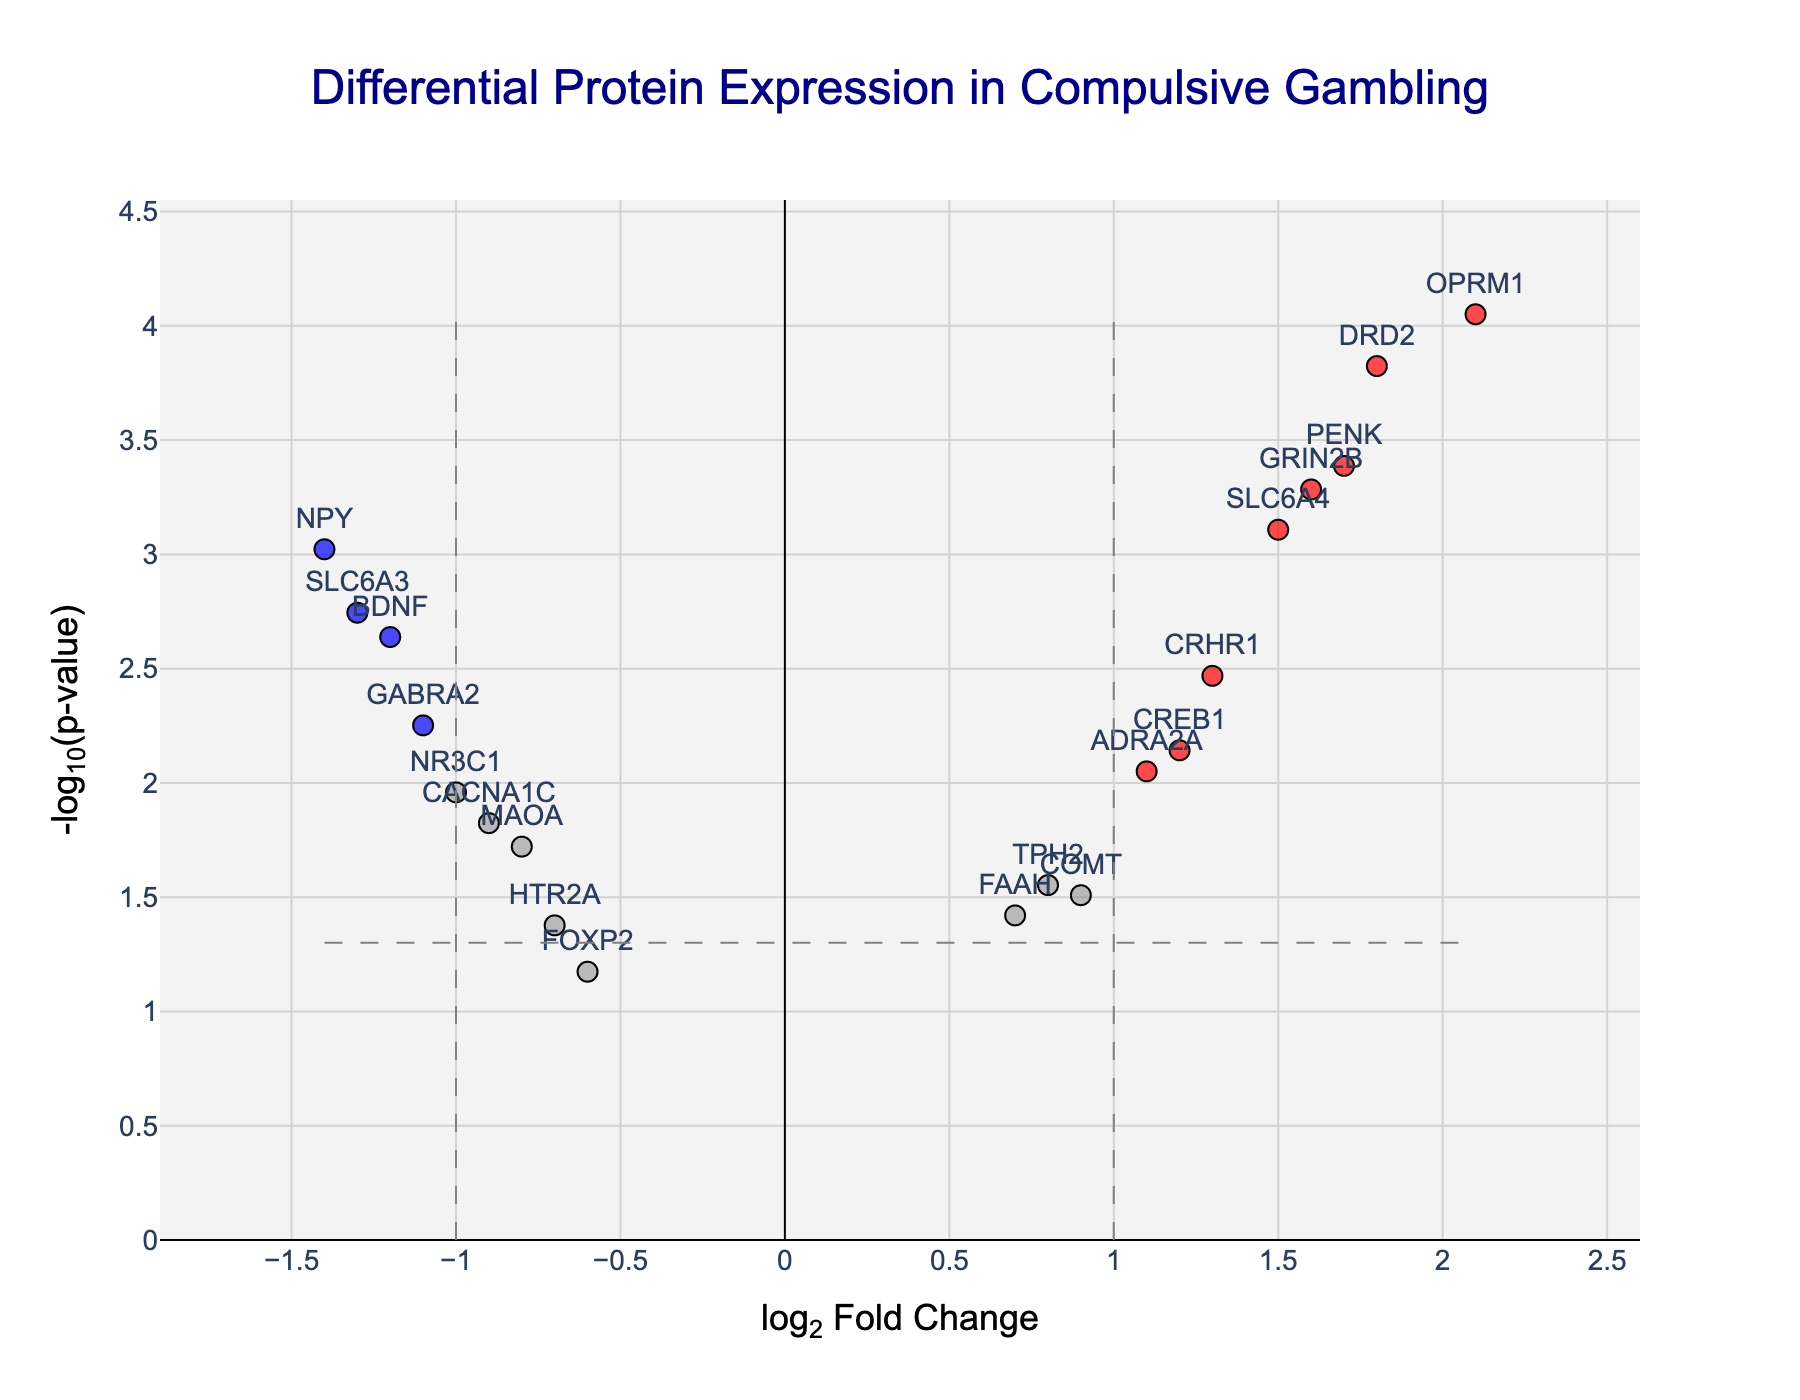What's the title of the plot? The title of the plot is displayed at the top center of the visual and reads "Differential Protein Expression in Compulsive Gambling".
Answer: Differential Protein Expression in Compulsive Gambling What does the x-axis represent? The x-axis represents the log2 fold change, which shows the change in expression level of proteins on a log2 scale.
Answer: log2 Fold Change How many proteins are significantly upregulated? Proteins that are significantly upregulated are shown in red and have a p-value less than 0.05 and log2 fold change greater than 1. Counting the red dots gives us the number.
Answer: 6 Which protein has the highest log2 fold change and what is it? Locate the point the farthest to the right on the x-axis with the text label, which represents the protein with the highest log2 fold change.
Answer: OPRM1, 2.1 What does the color blue signify on the plot? The blue color indicates significantly downregulated proteins which have a p-value less than 0.05 and log2 fold change less than -1.
Answer: Significantly downregulated proteins What is the log2 fold change and p-value of the protein BDNF? Find the point labeled BDNF on the plot and use the hover text to derive log2 fold change and p-value.
Answer: -1.2, 0.0023 How many proteins have a log2 fold change greater than 0 but are not statistically significant? Proteins with log2 fold change greater than 0 but not significant are gray dots on the right side of the vertical threshold line. Count them.
Answer: 3 Compare the significance level threshold on the plot with the p-value of CREB1. Is CREB1 statistically significant? The significance level threshold is represented by a horizontal gray dashed line at -log10(0.05). Compare this with the -log10(p-value) of CREB1 from hover text.
Answer: Yes Which protein has the lowest p-value and what is it? Identify the point highest on the y-axis (representing -log10(p-value)) with a label.
Answer: OPRM1, 0.000089 Are there more upregulated or downregulated proteins with p-value less than 0.05? Count the red (upregulated) and blue (downregulated) proteins marked with p-value less than 0.05. Compare the counts.
Answer: More upregulated 